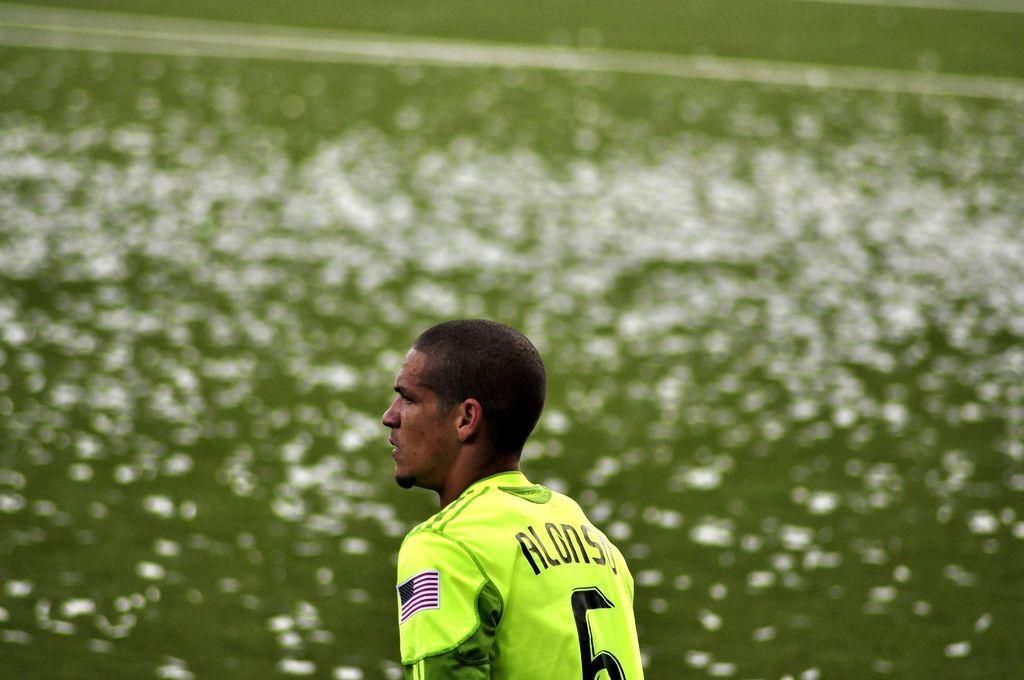Please provide a concise description of this image. In this image I can see a person wearing a yellow color t-shirt at bottom. 